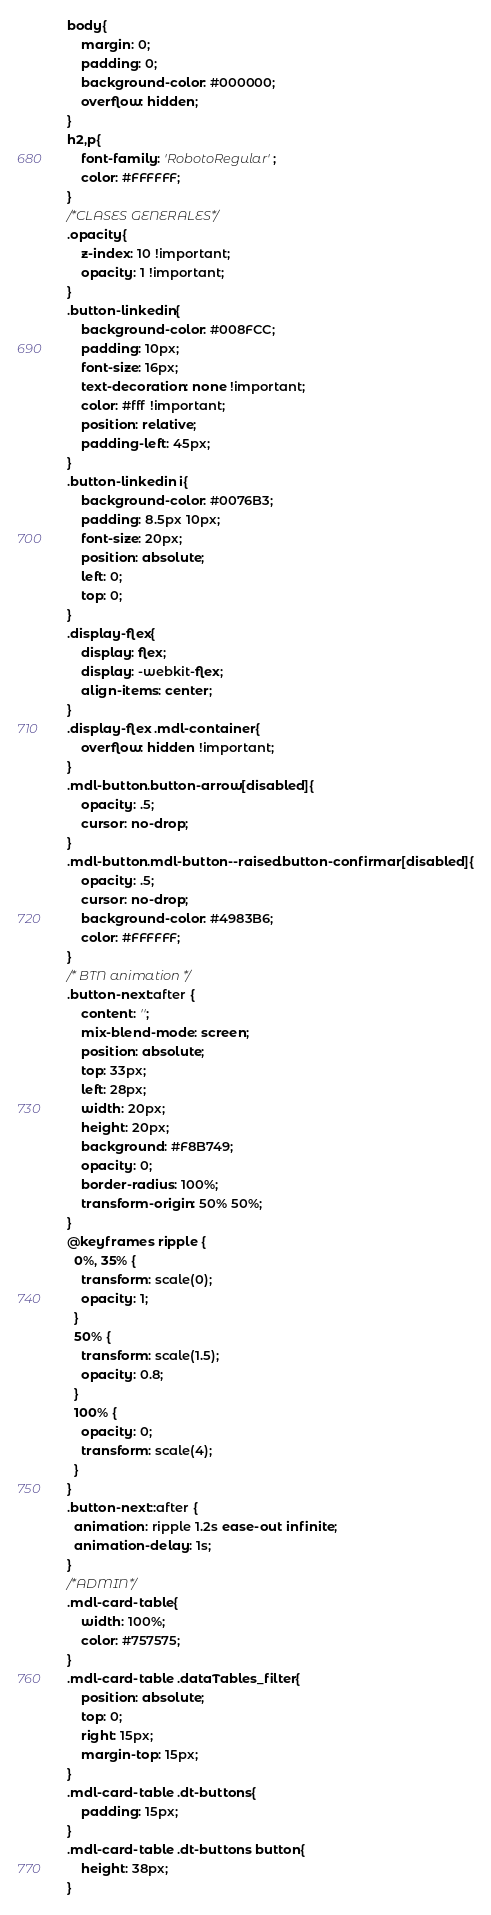Convert code to text. <code><loc_0><loc_0><loc_500><loc_500><_CSS_>body{
	margin: 0;
	padding: 0;
	background-color: #000000;
	overflow: hidden;
}
h2,p{
    font-family: 'RobotoRegular';
    color: #FFFFFF;
}
/*CLASES GENERALES*/
.opacity{
	z-index: 10 !important;
	opacity: 1 !important;
}
.button-linkedin{
    background-color: #008FCC;
    padding: 10px;
    font-size: 16px;
    text-decoration: none !important;
    color: #fff !important;
    position: relative;
    padding-left: 45px;
}
.button-linkedin i{
    background-color: #0076B3;
    padding: 8.5px 10px;
    font-size: 20px;
    position: absolute;
    left: 0;
    top: 0;
}
.display-flex{
	display: flex;
	display: -webkit-flex;
	align-items: center;
}
.display-flex .mdl-container{
	overflow: hidden !important;
}
.mdl-button.button-arrow[disabled]{
	opacity: .5;
	cursor: no-drop;
}
.mdl-button.mdl-button--raised.button-confirmar[disabled]{
	opacity: .5;
	cursor: no-drop;
	background-color: #4983B6; 
	color: #FFFFFF;
}
/* BTN animation */
.button-next:after {
	content: '';
    mix-blend-mode: screen;
    position: absolute;
    top: 33px;
    left: 28px;
    width: 20px;
    height: 20px;
    background: #F8B749;
    opacity: 0;
    border-radius: 100%;
    transform-origin: 50% 50%;
}
@keyframes ripple {
  0%, 35% {
    transform: scale(0);
    opacity: 1;
  }
  50% {
    transform: scale(1.5);
    opacity: 0.8;
  }
  100% {
    opacity: 0;
    transform: scale(4);
  }
}
.button-next::after {
  animation: ripple 1.2s ease-out infinite;
  animation-delay: 1s;
}
/*ADMIN*/
.mdl-card-table{
	width: 100%;
	color: #757575;
}
.mdl-card-table .dataTables_filter{
    position: absolute;
    top: 0;
    right: 15px;
    margin-top: 15px;
}
.mdl-card-table .dt-buttons{
	padding: 15px;
}
.mdl-card-table .dt-buttons button{
	height: 38px;
}</code> 